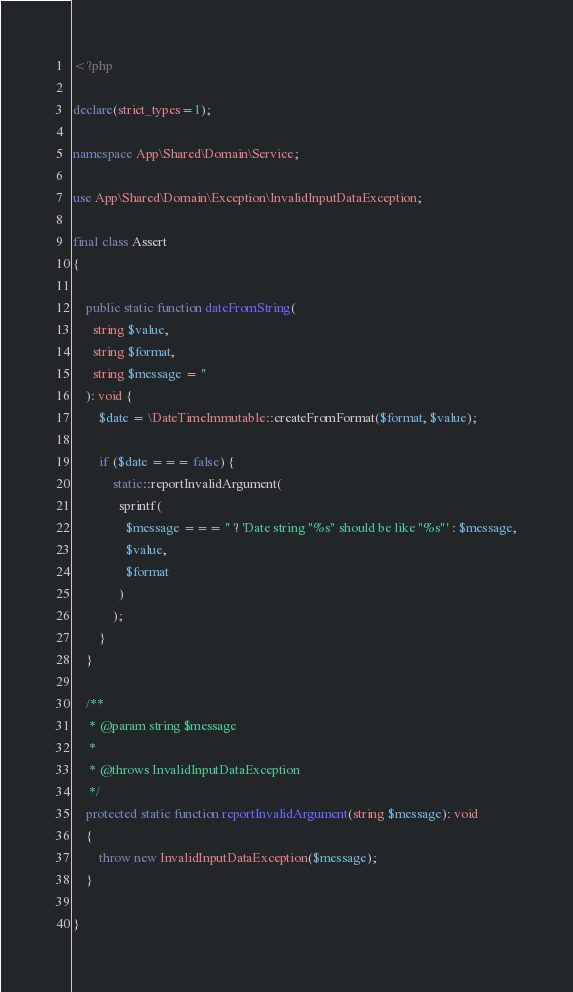Convert code to text. <code><loc_0><loc_0><loc_500><loc_500><_PHP_><?php

declare(strict_types=1);

namespace App\Shared\Domain\Service;

use App\Shared\Domain\Exception\InvalidInputDataException;

final class Assert
{

    public static function dateFromString(
      string $value,
      string $format,
      string $message = ''
    ): void {
        $date = \DateTimeImmutable::createFromFormat($format, $value);

        if ($date === false) {
            static::reportInvalidArgument(
              sprintf(
                $message === '' ? 'Date string "%s" should be like "%s"' : $message,
                $value,
                $format
              )
            );
        }
    }

    /**
     * @param string $message
     *
     * @throws InvalidInputDataException
     */
    protected static function reportInvalidArgument(string $message): void
    {
        throw new InvalidInputDataException($message);
    }

}</code> 